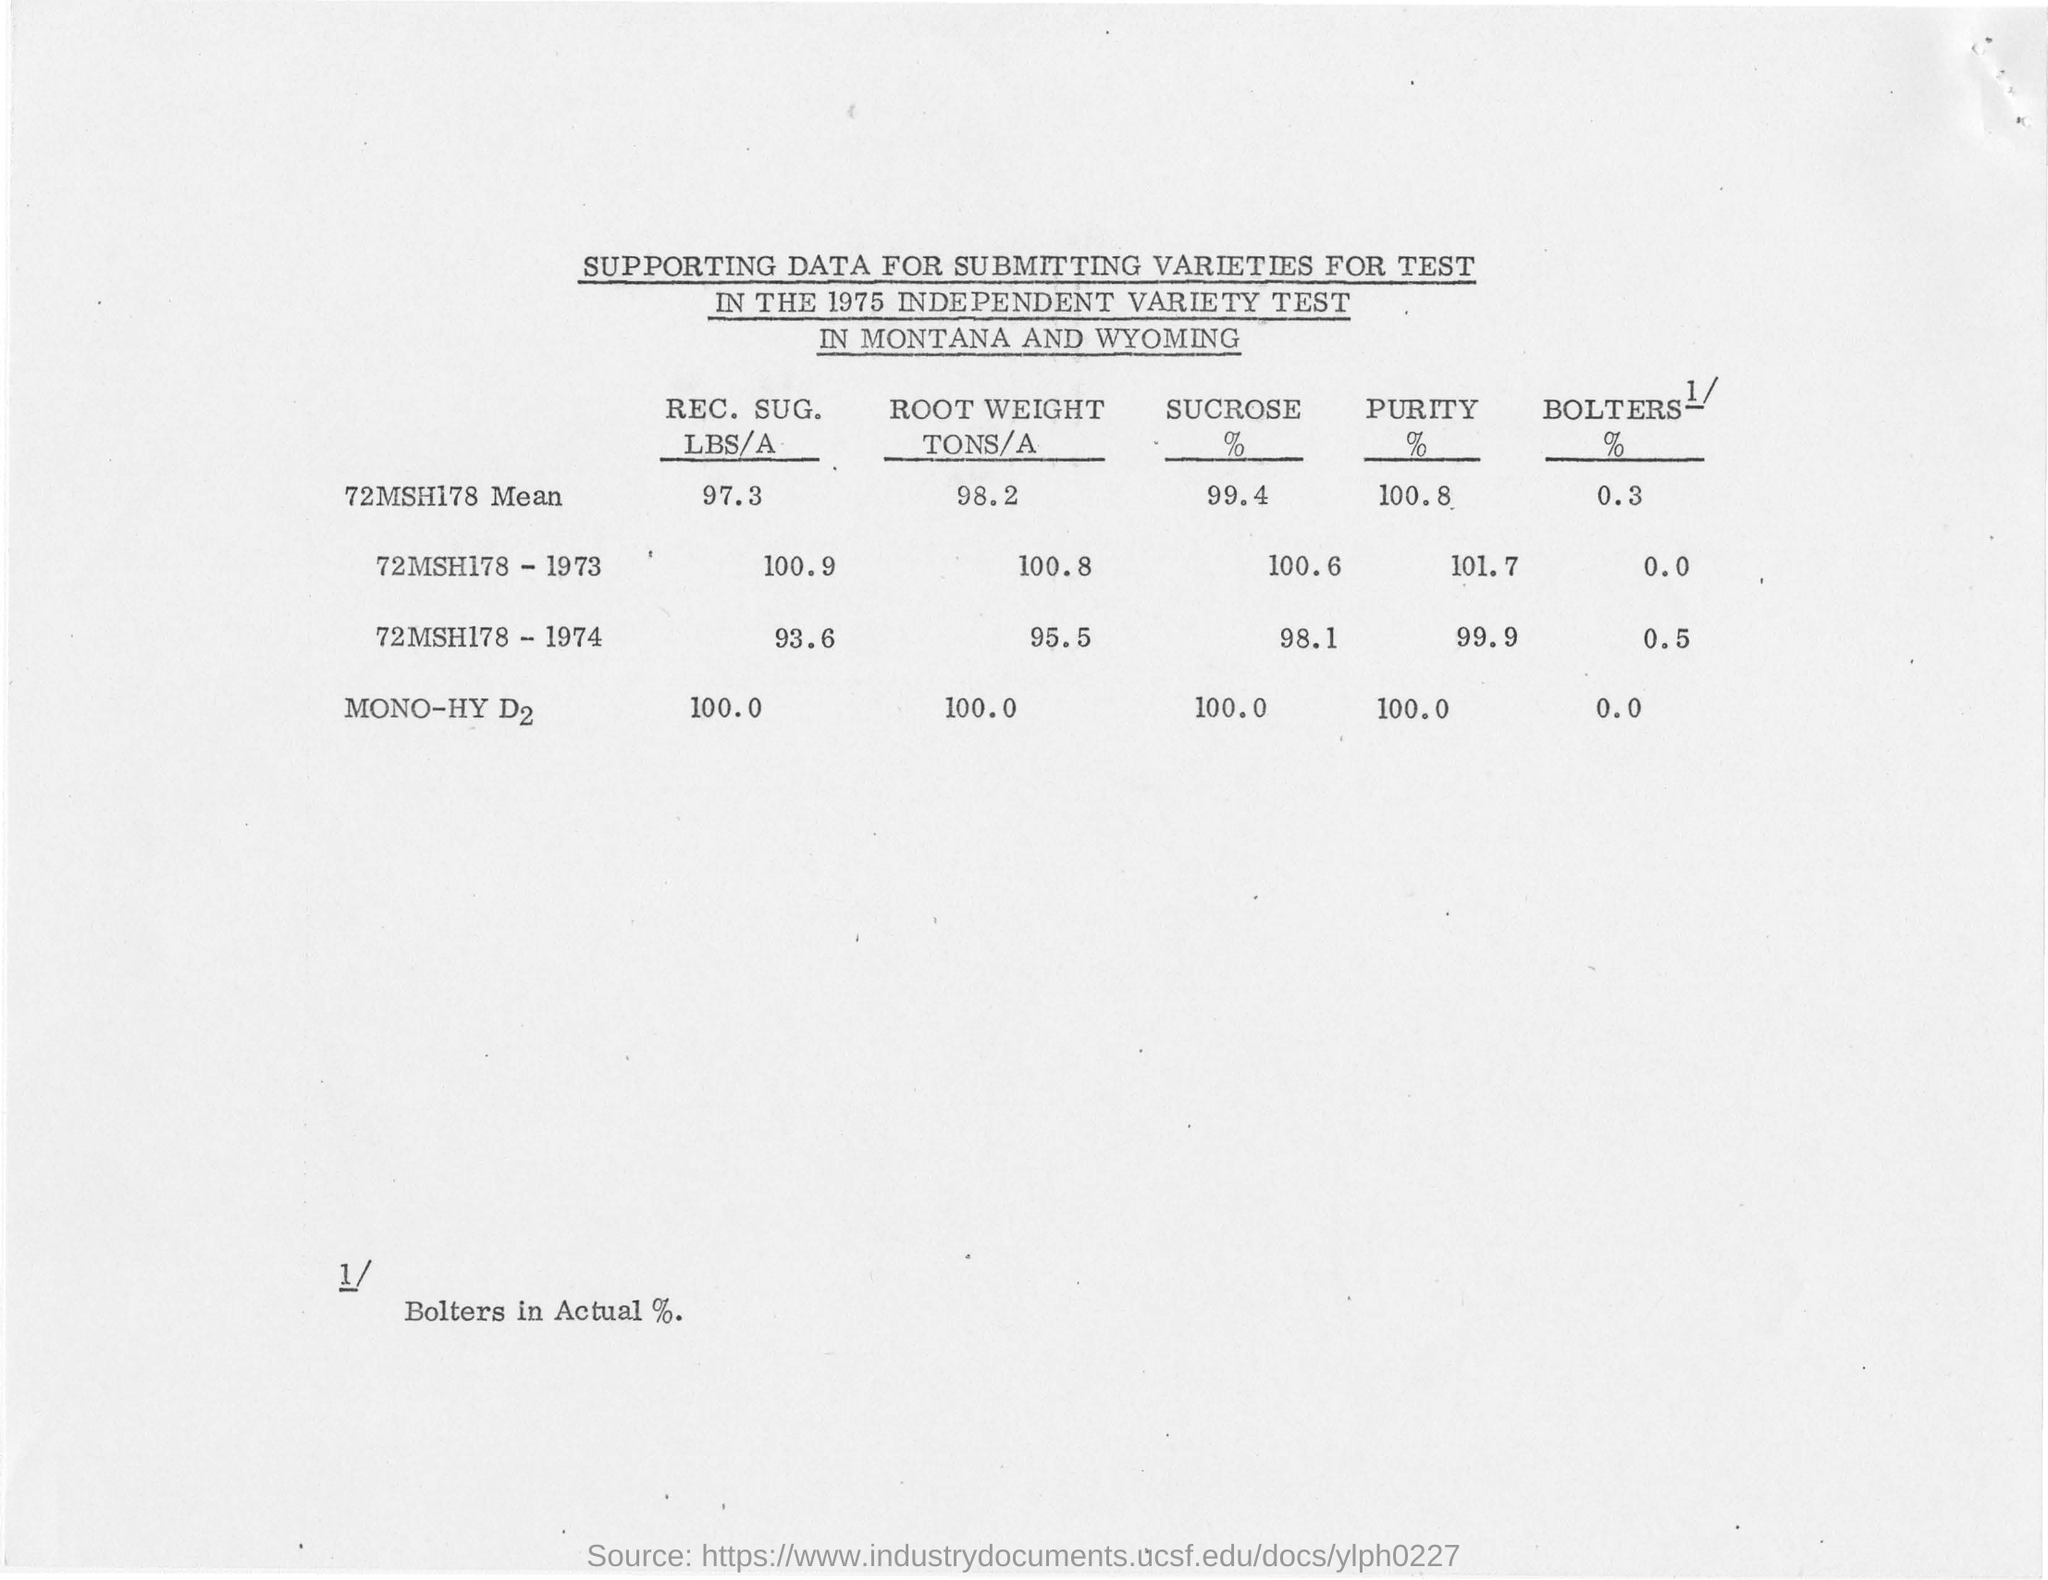Specify some key components in this picture. The test was conducted in Montana and Wyoming. The test was conducted in 1975. The purity of mono-hydrogen d2 is 100.0%. The sucrose percentage of 72MSH178 is 99.4%. 